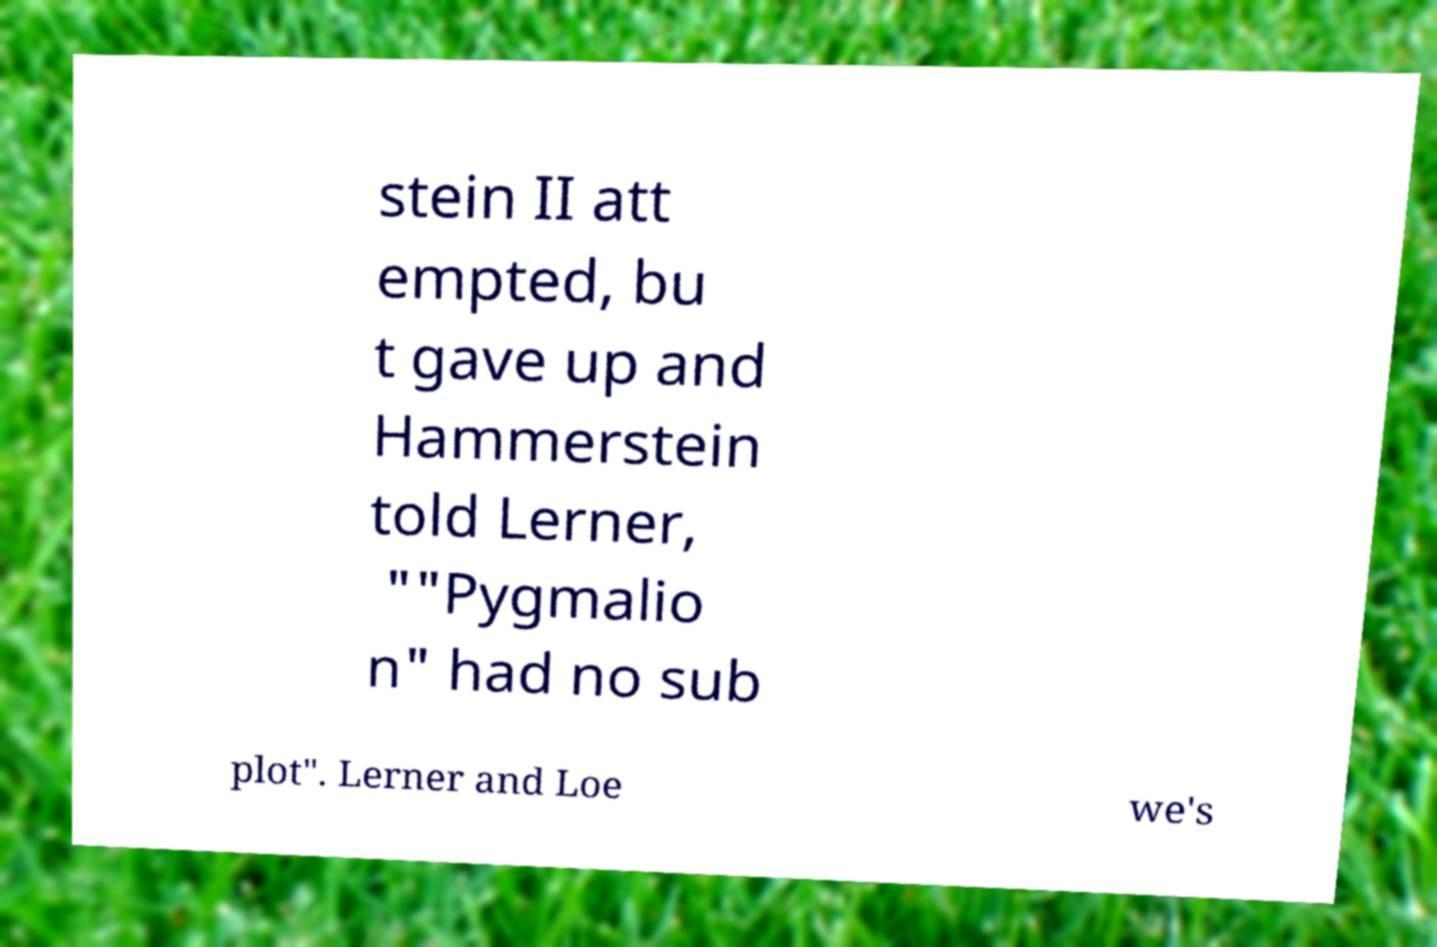For documentation purposes, I need the text within this image transcribed. Could you provide that? stein II att empted, bu t gave up and Hammerstein told Lerner, ""Pygmalio n" had no sub plot". Lerner and Loe we's 